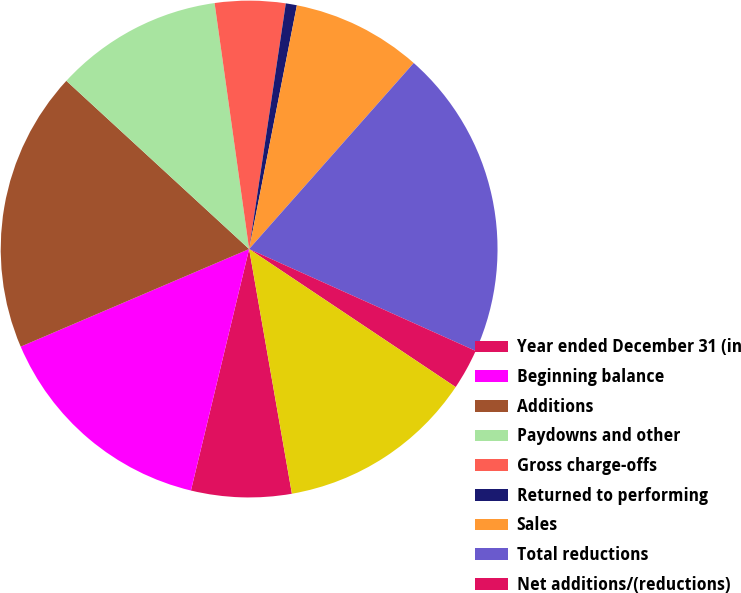Convert chart. <chart><loc_0><loc_0><loc_500><loc_500><pie_chart><fcel>Year ended December 31 (in<fcel>Beginning balance<fcel>Additions<fcel>Paydowns and other<fcel>Gross charge-offs<fcel>Returned to performing<fcel>Sales<fcel>Total reductions<fcel>Net additions/(reductions)<fcel>Ending balance<nl><fcel>6.52%<fcel>14.81%<fcel>18.27%<fcel>10.94%<fcel>4.58%<fcel>0.72%<fcel>8.45%<fcel>20.2%<fcel>2.65%<fcel>12.87%<nl></chart> 